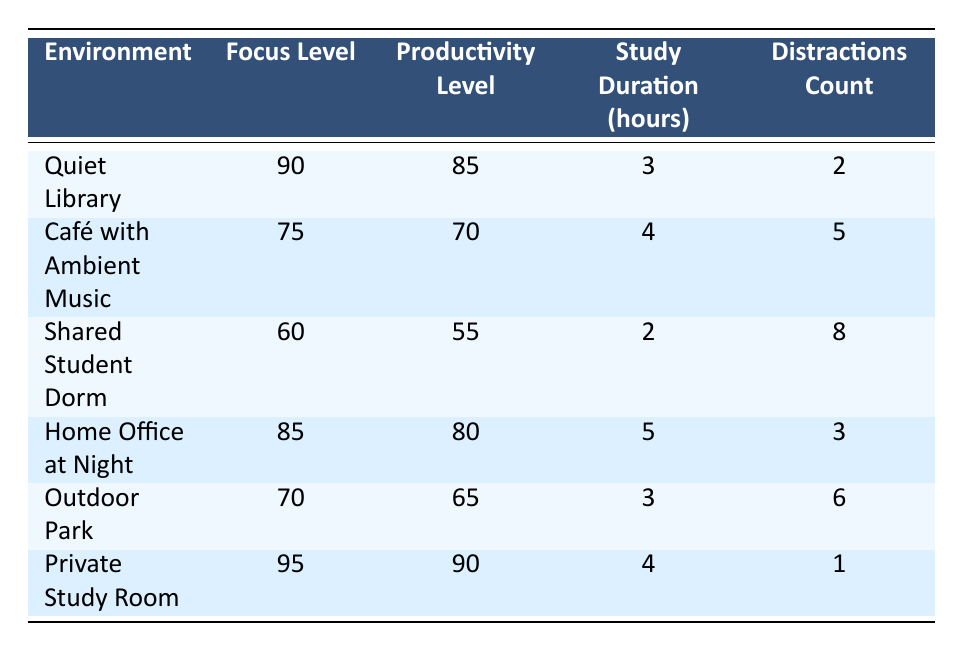What is the focus level in a Quiet Library? The focus level for the Quiet Library is directly provided in the table as 90.
Answer: 90 What is the least number of distractions recorded in any study environment? By examining the distractions count, the least number is 1, found in the Private Study Room.
Answer: 1 Which environment has the highest productivity level? The Private Study Room has the highest productivity level at 90, as indicated in the respective column.
Answer: Private Study Room What is the average study duration across all environments? The total study duration is (3 + 4 + 2 + 5 + 3 + 4) = 21 hours for 6 environments, so the average is 21 / 6 = 3.5 hours.
Answer: 3.5 Is the focus level in a Café with Ambient Music higher than in a Shared Student Dorm? The focus level in the Café with Ambient Music is 75, while in the Shared Student Dorm it is 60, thus it is true that the Café has a higher focus level.
Answer: Yes If a student studies in a Private Study Room for 4 hours, how many distractions will they likely face? According to the table, in the Private Study Room, the distractions count is recorded as 1, independent of study duration.
Answer: 1 Calculate the difference in focus levels between the Quiet Library and the Home Office at Night. The focus level in the Quiet Library is 90 and in the Home Office at Night is 85. The difference is 90 - 85 = 5.
Answer: 5 Which study environment has a focus level below 70 and what is its productivity level? The Shared Student Dorm has a focus level of 60, which is below 70, and its productivity level is 55, as shown in the table.
Answer: 55 Is it true that the focus level in the Outdoor Park is greater than that in a Café with Ambient Music? The focus level in the Outdoor Park is 70, while in the Café with Ambient Music it is 75, therefore this statement is false.
Answer: No 